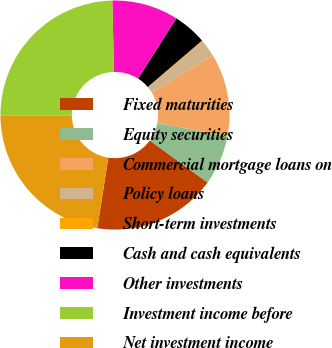Convert chart to OTSL. <chart><loc_0><loc_0><loc_500><loc_500><pie_chart><fcel>Fixed maturities<fcel>Equity securities<fcel>Commercial mortgage loans on<fcel>Policy loans<fcel>Short-term investments<fcel>Cash and cash equivalents<fcel>Other investments<fcel>Investment income before<fcel>Net investment income<nl><fcel>17.45%<fcel>7.06%<fcel>11.69%<fcel>2.42%<fcel>0.11%<fcel>4.74%<fcel>9.37%<fcel>24.74%<fcel>22.43%<nl></chart> 